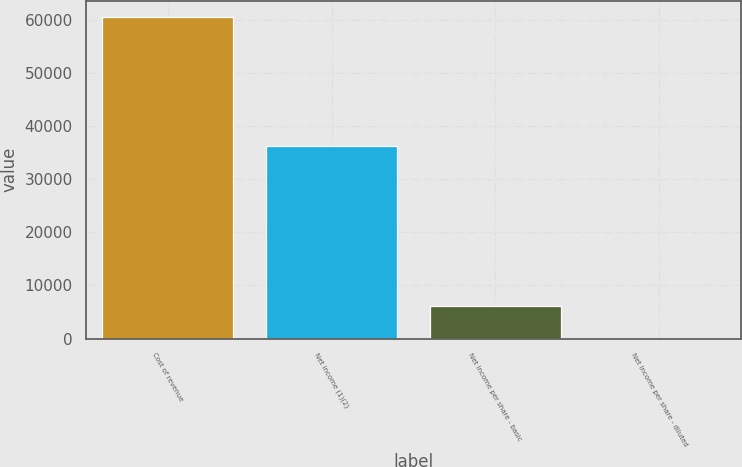<chart> <loc_0><loc_0><loc_500><loc_500><bar_chart><fcel>Cost of revenue<fcel>Net income (1)(2)<fcel>Net income per share - basic<fcel>Net income per share - diluted<nl><fcel>60585<fcel>36259<fcel>6058.61<fcel>0.12<nl></chart> 